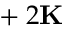<formula> <loc_0><loc_0><loc_500><loc_500>\varepsilon + 2 K</formula> 